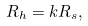Convert formula to latex. <formula><loc_0><loc_0><loc_500><loc_500>R _ { h } = k R _ { s } ,</formula> 